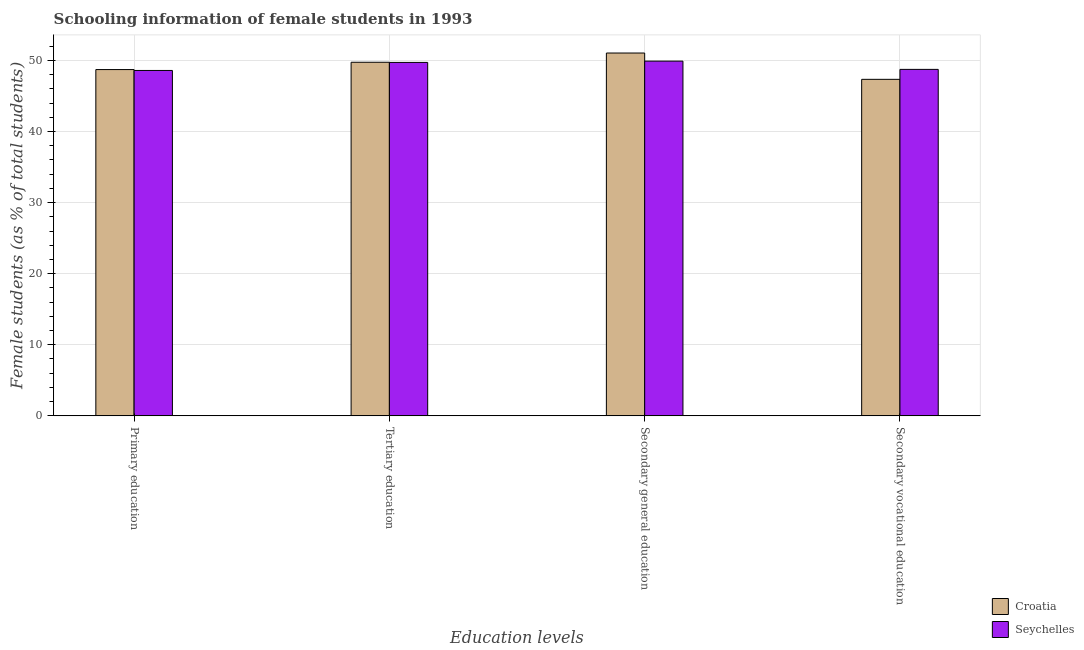How many bars are there on the 3rd tick from the right?
Offer a very short reply. 2. What is the percentage of female students in secondary vocational education in Croatia?
Offer a terse response. 47.34. Across all countries, what is the maximum percentage of female students in secondary vocational education?
Provide a succinct answer. 48.74. Across all countries, what is the minimum percentage of female students in tertiary education?
Your answer should be very brief. 49.72. In which country was the percentage of female students in secondary vocational education maximum?
Give a very brief answer. Seychelles. In which country was the percentage of female students in tertiary education minimum?
Offer a very short reply. Seychelles. What is the total percentage of female students in tertiary education in the graph?
Your answer should be very brief. 99.46. What is the difference between the percentage of female students in secondary vocational education in Croatia and that in Seychelles?
Your response must be concise. -1.4. What is the difference between the percentage of female students in primary education in Croatia and the percentage of female students in secondary vocational education in Seychelles?
Provide a short and direct response. -0.03. What is the average percentage of female students in tertiary education per country?
Offer a terse response. 49.73. What is the difference between the percentage of female students in primary education and percentage of female students in secondary vocational education in Croatia?
Keep it short and to the point. 1.37. What is the ratio of the percentage of female students in secondary education in Seychelles to that in Croatia?
Offer a very short reply. 0.98. Is the percentage of female students in secondary education in Seychelles less than that in Croatia?
Provide a succinct answer. Yes. Is the difference between the percentage of female students in secondary vocational education in Croatia and Seychelles greater than the difference between the percentage of female students in secondary education in Croatia and Seychelles?
Ensure brevity in your answer.  No. What is the difference between the highest and the second highest percentage of female students in secondary vocational education?
Give a very brief answer. 1.4. What is the difference between the highest and the lowest percentage of female students in secondary education?
Offer a very short reply. 1.14. In how many countries, is the percentage of female students in secondary vocational education greater than the average percentage of female students in secondary vocational education taken over all countries?
Provide a succinct answer. 1. Is the sum of the percentage of female students in secondary vocational education in Seychelles and Croatia greater than the maximum percentage of female students in secondary education across all countries?
Provide a short and direct response. Yes. What does the 2nd bar from the left in Primary education represents?
Your answer should be very brief. Seychelles. What does the 2nd bar from the right in Secondary general education represents?
Your answer should be compact. Croatia. How many bars are there?
Offer a terse response. 8. Where does the legend appear in the graph?
Keep it short and to the point. Bottom right. How are the legend labels stacked?
Offer a terse response. Vertical. What is the title of the graph?
Keep it short and to the point. Schooling information of female students in 1993. What is the label or title of the X-axis?
Your answer should be compact. Education levels. What is the label or title of the Y-axis?
Make the answer very short. Female students (as % of total students). What is the Female students (as % of total students) in Croatia in Primary education?
Your response must be concise. 48.71. What is the Female students (as % of total students) of Seychelles in Primary education?
Your answer should be very brief. 48.59. What is the Female students (as % of total students) of Croatia in Tertiary education?
Offer a terse response. 49.74. What is the Female students (as % of total students) of Seychelles in Tertiary education?
Provide a succinct answer. 49.72. What is the Female students (as % of total students) of Croatia in Secondary general education?
Provide a short and direct response. 51.04. What is the Female students (as % of total students) in Seychelles in Secondary general education?
Keep it short and to the point. 49.9. What is the Female students (as % of total students) of Croatia in Secondary vocational education?
Make the answer very short. 47.34. What is the Female students (as % of total students) in Seychelles in Secondary vocational education?
Your response must be concise. 48.74. Across all Education levels, what is the maximum Female students (as % of total students) of Croatia?
Offer a very short reply. 51.04. Across all Education levels, what is the maximum Female students (as % of total students) of Seychelles?
Provide a succinct answer. 49.9. Across all Education levels, what is the minimum Female students (as % of total students) in Croatia?
Give a very brief answer. 47.34. Across all Education levels, what is the minimum Female students (as % of total students) in Seychelles?
Your answer should be very brief. 48.59. What is the total Female students (as % of total students) of Croatia in the graph?
Offer a terse response. 196.83. What is the total Female students (as % of total students) in Seychelles in the graph?
Your response must be concise. 196.95. What is the difference between the Female students (as % of total students) in Croatia in Primary education and that in Tertiary education?
Make the answer very short. -1.03. What is the difference between the Female students (as % of total students) in Seychelles in Primary education and that in Tertiary education?
Provide a short and direct response. -1.13. What is the difference between the Female students (as % of total students) in Croatia in Primary education and that in Secondary general education?
Keep it short and to the point. -2.33. What is the difference between the Female students (as % of total students) of Seychelles in Primary education and that in Secondary general education?
Offer a terse response. -1.32. What is the difference between the Female students (as % of total students) in Croatia in Primary education and that in Secondary vocational education?
Provide a short and direct response. 1.37. What is the difference between the Female students (as % of total students) in Seychelles in Primary education and that in Secondary vocational education?
Give a very brief answer. -0.15. What is the difference between the Female students (as % of total students) in Croatia in Tertiary education and that in Secondary general education?
Keep it short and to the point. -1.3. What is the difference between the Female students (as % of total students) in Seychelles in Tertiary education and that in Secondary general education?
Your response must be concise. -0.18. What is the difference between the Female students (as % of total students) in Croatia in Tertiary education and that in Secondary vocational education?
Offer a terse response. 2.4. What is the difference between the Female students (as % of total students) of Seychelles in Tertiary education and that in Secondary vocational education?
Give a very brief answer. 0.98. What is the difference between the Female students (as % of total students) in Croatia in Secondary general education and that in Secondary vocational education?
Ensure brevity in your answer.  3.7. What is the difference between the Female students (as % of total students) in Seychelles in Secondary general education and that in Secondary vocational education?
Your answer should be compact. 1.16. What is the difference between the Female students (as % of total students) of Croatia in Primary education and the Female students (as % of total students) of Seychelles in Tertiary education?
Your answer should be compact. -1.01. What is the difference between the Female students (as % of total students) in Croatia in Primary education and the Female students (as % of total students) in Seychelles in Secondary general education?
Offer a terse response. -1.19. What is the difference between the Female students (as % of total students) in Croatia in Primary education and the Female students (as % of total students) in Seychelles in Secondary vocational education?
Provide a short and direct response. -0.03. What is the difference between the Female students (as % of total students) in Croatia in Tertiary education and the Female students (as % of total students) in Seychelles in Secondary general education?
Provide a short and direct response. -0.16. What is the difference between the Female students (as % of total students) of Croatia in Secondary general education and the Female students (as % of total students) of Seychelles in Secondary vocational education?
Keep it short and to the point. 2.3. What is the average Female students (as % of total students) of Croatia per Education levels?
Offer a very short reply. 49.21. What is the average Female students (as % of total students) in Seychelles per Education levels?
Provide a succinct answer. 49.24. What is the difference between the Female students (as % of total students) of Croatia and Female students (as % of total students) of Seychelles in Primary education?
Make the answer very short. 0.13. What is the difference between the Female students (as % of total students) of Croatia and Female students (as % of total students) of Seychelles in Tertiary education?
Provide a short and direct response. 0.02. What is the difference between the Female students (as % of total students) of Croatia and Female students (as % of total students) of Seychelles in Secondary general education?
Ensure brevity in your answer.  1.14. What is the difference between the Female students (as % of total students) in Croatia and Female students (as % of total students) in Seychelles in Secondary vocational education?
Ensure brevity in your answer.  -1.4. What is the ratio of the Female students (as % of total students) in Croatia in Primary education to that in Tertiary education?
Keep it short and to the point. 0.98. What is the ratio of the Female students (as % of total students) of Seychelles in Primary education to that in Tertiary education?
Your response must be concise. 0.98. What is the ratio of the Female students (as % of total students) in Croatia in Primary education to that in Secondary general education?
Offer a very short reply. 0.95. What is the ratio of the Female students (as % of total students) of Seychelles in Primary education to that in Secondary general education?
Offer a very short reply. 0.97. What is the ratio of the Female students (as % of total students) of Croatia in Primary education to that in Secondary vocational education?
Your response must be concise. 1.03. What is the ratio of the Female students (as % of total students) of Croatia in Tertiary education to that in Secondary general education?
Your answer should be very brief. 0.97. What is the ratio of the Female students (as % of total students) in Croatia in Tertiary education to that in Secondary vocational education?
Give a very brief answer. 1.05. What is the ratio of the Female students (as % of total students) of Seychelles in Tertiary education to that in Secondary vocational education?
Make the answer very short. 1.02. What is the ratio of the Female students (as % of total students) of Croatia in Secondary general education to that in Secondary vocational education?
Keep it short and to the point. 1.08. What is the ratio of the Female students (as % of total students) in Seychelles in Secondary general education to that in Secondary vocational education?
Your answer should be compact. 1.02. What is the difference between the highest and the second highest Female students (as % of total students) in Croatia?
Give a very brief answer. 1.3. What is the difference between the highest and the second highest Female students (as % of total students) of Seychelles?
Ensure brevity in your answer.  0.18. What is the difference between the highest and the lowest Female students (as % of total students) of Croatia?
Make the answer very short. 3.7. What is the difference between the highest and the lowest Female students (as % of total students) in Seychelles?
Offer a terse response. 1.32. 